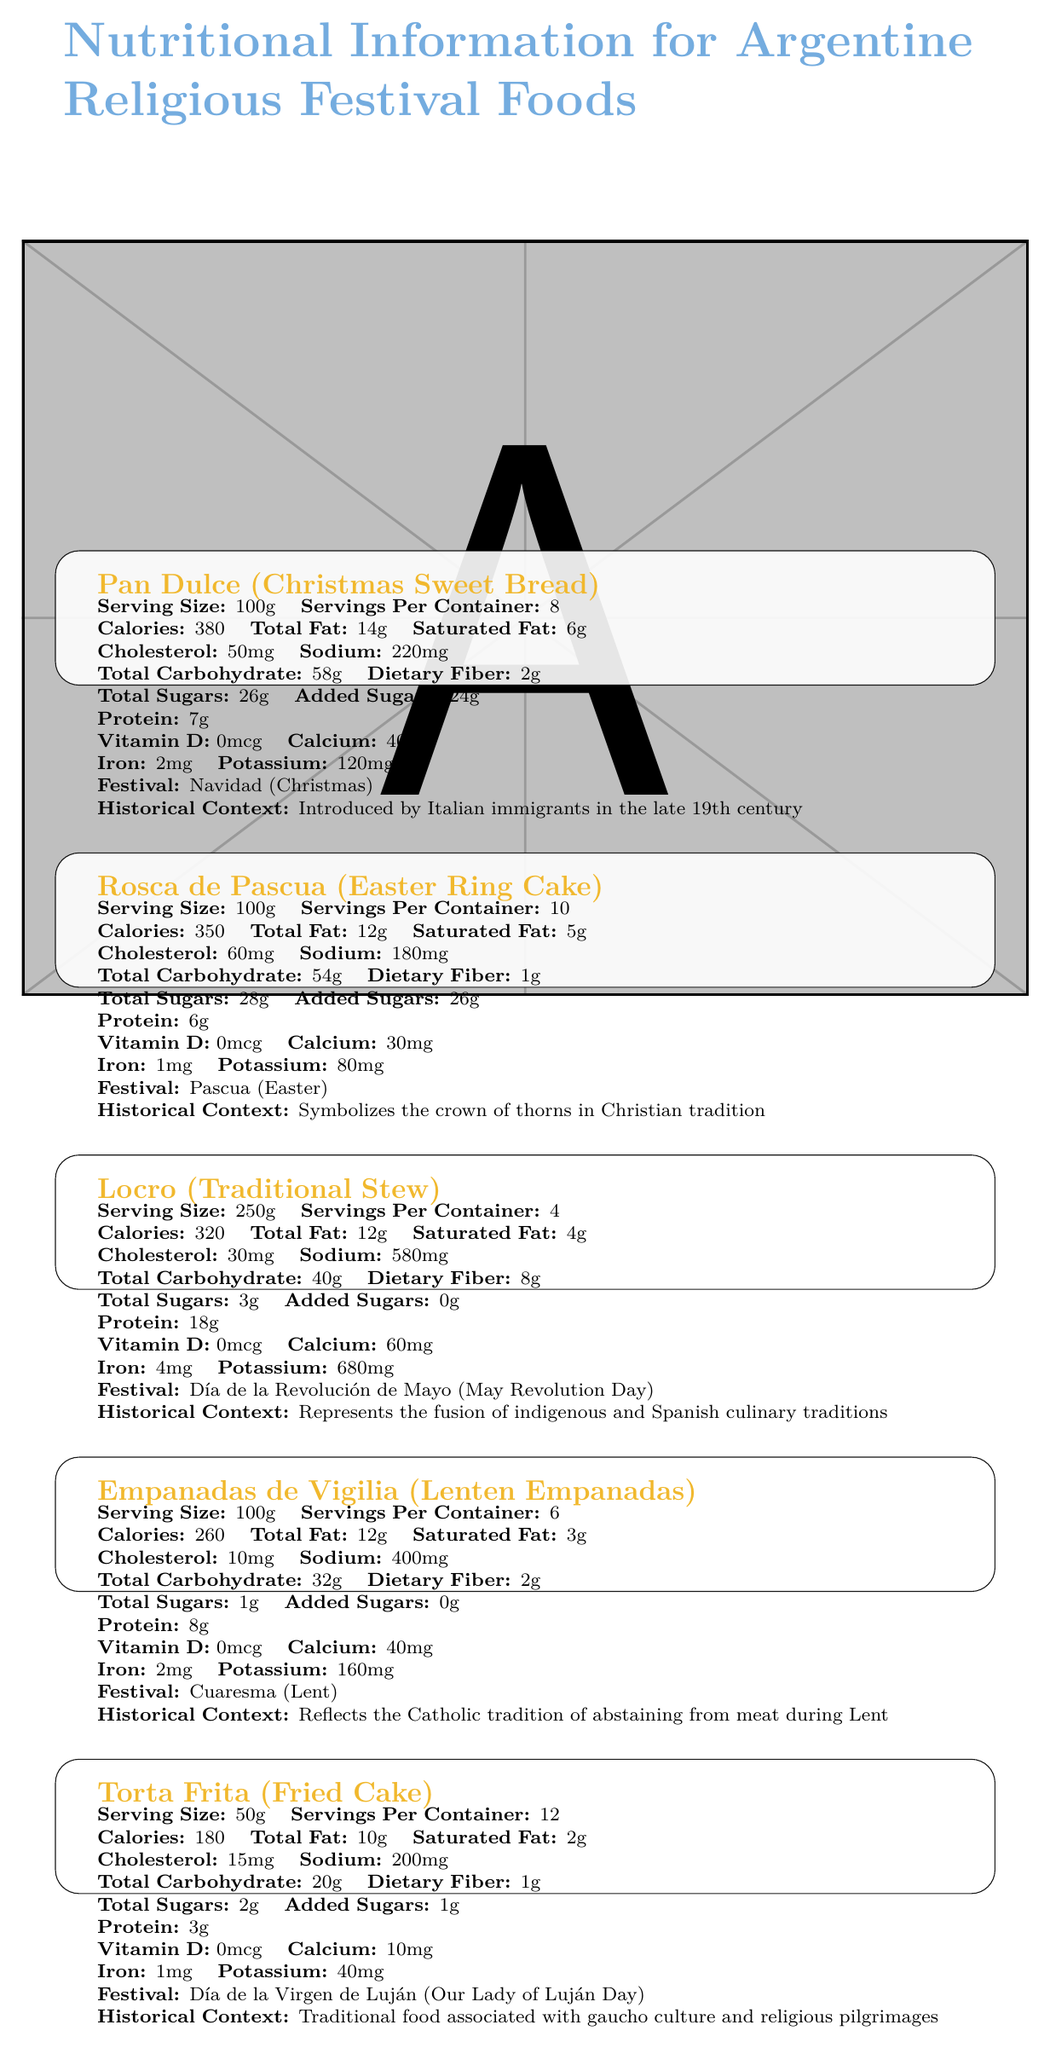what is the historical context of Pan Dulce? The document states that Pan Dulce was introduced by Italian immigrants in the late 19th century.
Answer: Introduced by Italian immigrants in the late 19th century how much sodium does a serving of Locro contain? According to the document, a serving of Locro contains 580mg of sodium.
Answer: 580mg what is the serving size for Torta Frita? The serving size for Torta Frita is listed as 50g in the document.
Answer: 50g does Rosca de Pascua contain any trans fats? The document specifies that Rosca de Pascua contains 0g of trans fats.
Answer: No how much protein is in a serving of Empanadas de Vigilia? The document states that a serving of Empanadas de Vigilia contains 8g of protein.
Answer: 8g which food is associated with Día de la Revolución de Mayo? A. Rosca de Pascua B. Pan Dulce C. Locro D. Torta Frita The document specifies that Locro is associated with Día de la Revolución de Mayo.
Answer: C. Locro which festival is Pan Dulce associated with? A. Christmas B. Easter C. Lent D. May Revolution Day The document lists Christmas (Navidad) as the associated festival for Pan Dulce.
Answer: A. Christmas is Torta Frita high in saturated fat? Torta Frita contains 2g of saturated fat per serving, which is relatively low.
Answer: No summarize the main idea of the document. The document contains detailed nutritional data for five Argentine foods linked to specific religious festivals, explaining their cultural significance and historical origins.
Answer: The document provides nutritional information for traditional Argentine foods associated with religious festivals, including details about serving size, calories, nutrients, and historical context for each food item. what is the exact amount of iron in a serving of Rosca de Pascua? Rosca de Pascua contains 1mg of iron per serving as stated in the document.
Answer: 1mg is Locro high in dietary fiber? The document lists Locro as having 8g of dietary fiber per serving, which is considered high.
Answer: Yes how many servings per container are there for Empanadas de Vigilia? The document specifies that there are 6 servings per container for Empanadas de Vigilia.
Answer: 6 which food item has the highest total sugars per serving? The document shows Rosca de Pascua with 28g total sugars, the highest among the listed foods.
Answer: Rosca de Pascua what is the potassium content of Torta Frita? The document states that Torta Frita contains 40mg of potassium per serving.
Answer: 40mg how much cholesterol is in a serving of Pan Dulce? The document specifies that Pan Dulce contains 50mg of cholesterol per serving.
Answer: 50mg what reflects the Catholic tradition of abstaining from meat during Lent? The historical context section for Empanadas de Vigilia states that they reflect the Catholic tradition of abstaining from meat during Lent.
Answer: Empanadas de Vigilia how many servings are in a container of Rosca de Pascua? The document mentions that a container of Rosca de Pascua contains 10 servings.
Answer: 10 what is the added sugars content in a serving of Locro? The document indicates that Locro contains 0g of added sugars per serving.
Answer: 0g what is the calcium content of Pan Dulce? The document states that Pan Dulce contains 40mg of calcium per serving.
Answer: 40mg identify a food item that symbolizes the crown of thorns in Christian tradition. The historical context for Rosca de Pascua mentions that it symbolizes the crown of thorns in Christian tradition.
Answer: Rosca de Pascua why is Torta Frita associated with gaucho culture? The historical context for Torta Frita indicates its association with gaucho culture and religious pilgrimages.
Answer: Traditional food associated with gaucho culture and religious pilgrimages what is the total carbohydrate content in a serving of Rosca de Pascua? The document specifies that Rosca de Pascua contains 54g of total carbohydrate per serving.
Answer: 54g what is the main idea of the document? The document provides detailed nutritional data for various traditional foods linked to specific Argentine religious festivals, along with their historical significance.
Answer: Nutritional information for foods associated with religious festivals in Argentina, including historical context and nutrient content how much Vitamin D do the listed foods contain? The document does not provide sufficient details to calculate the total amount of Vitamin D across all listed foods.
Answer: Cannot be determined 